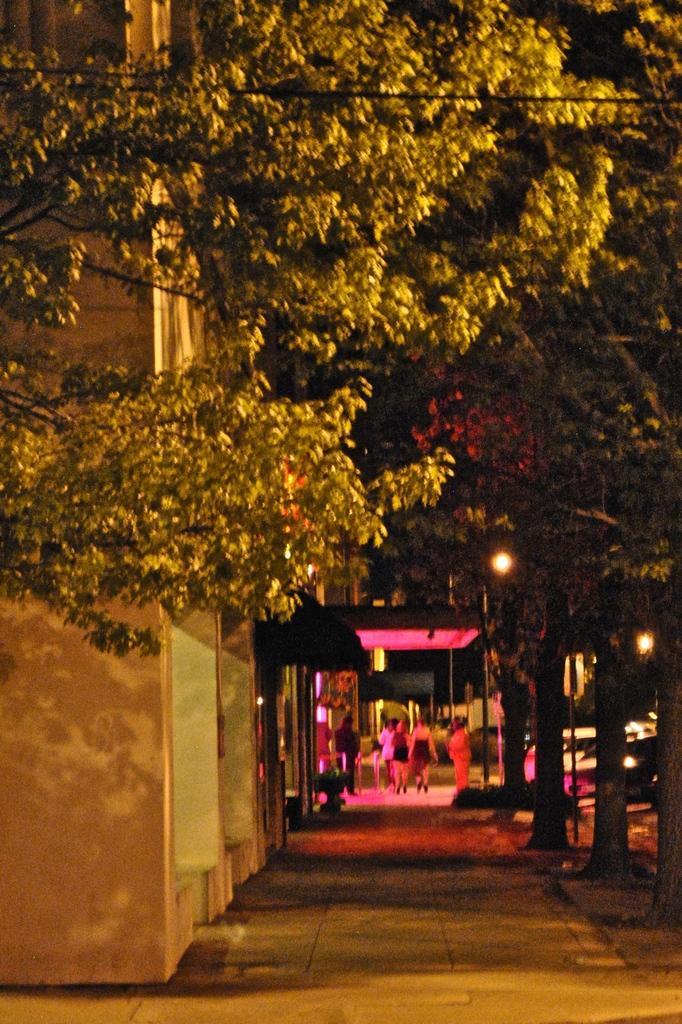How would you summarize this image in a sentence or two? In this image we can see a building, there are some trees, people, lights, poles, vehicles and potted plants. 